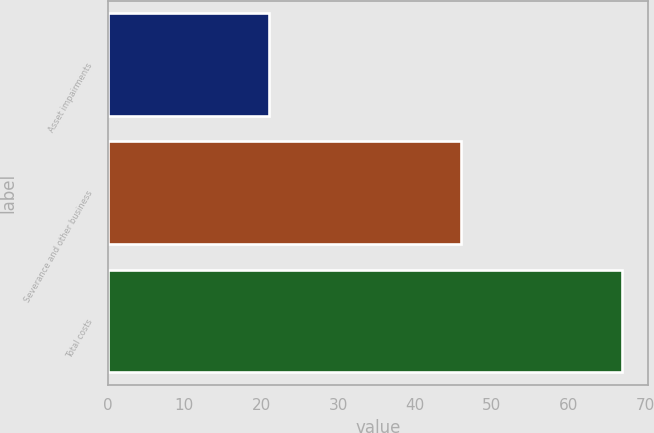<chart> <loc_0><loc_0><loc_500><loc_500><bar_chart><fcel>Asset impairments<fcel>Severance and other business<fcel>Total costs<nl><fcel>21<fcel>46<fcel>67<nl></chart> 